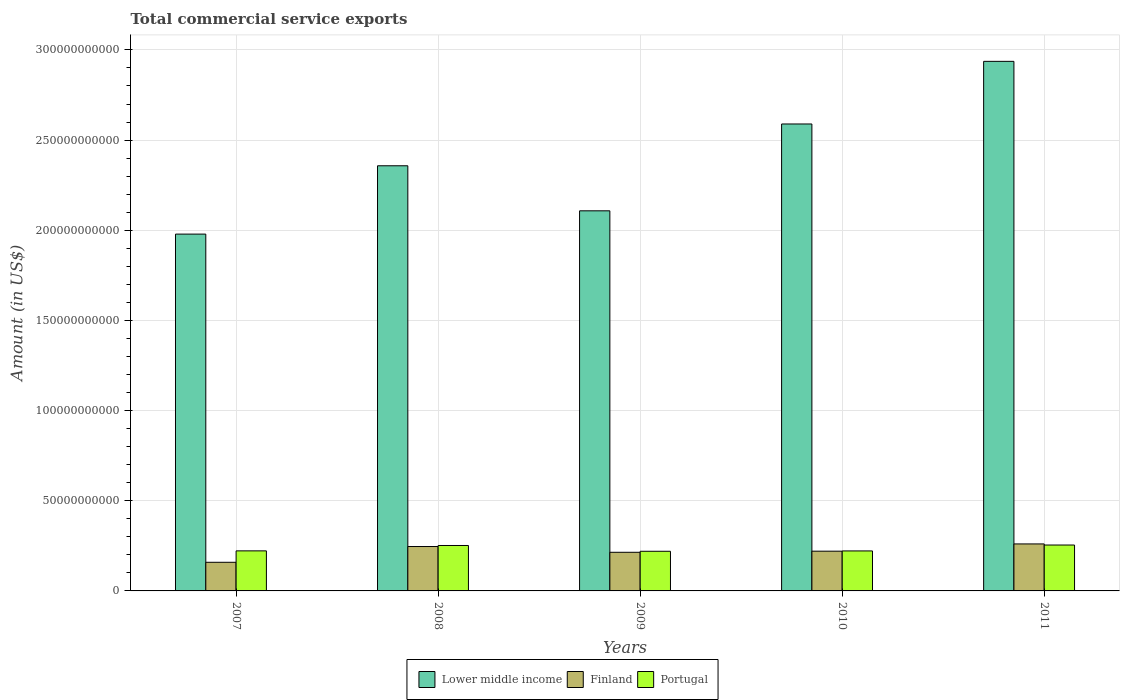How many different coloured bars are there?
Make the answer very short. 3. How many bars are there on the 1st tick from the left?
Keep it short and to the point. 3. What is the total commercial service exports in Lower middle income in 2011?
Your response must be concise. 2.94e+11. Across all years, what is the maximum total commercial service exports in Finland?
Offer a terse response. 2.61e+1. Across all years, what is the minimum total commercial service exports in Lower middle income?
Provide a succinct answer. 1.98e+11. In which year was the total commercial service exports in Lower middle income maximum?
Give a very brief answer. 2011. In which year was the total commercial service exports in Portugal minimum?
Your response must be concise. 2009. What is the total total commercial service exports in Finland in the graph?
Provide a succinct answer. 1.10e+11. What is the difference between the total commercial service exports in Lower middle income in 2009 and that in 2010?
Give a very brief answer. -4.82e+1. What is the difference between the total commercial service exports in Finland in 2008 and the total commercial service exports in Lower middle income in 2010?
Ensure brevity in your answer.  -2.34e+11. What is the average total commercial service exports in Finland per year?
Your response must be concise. 2.20e+1. In the year 2007, what is the difference between the total commercial service exports in Lower middle income and total commercial service exports in Portugal?
Your answer should be compact. 1.76e+11. What is the ratio of the total commercial service exports in Finland in 2007 to that in 2009?
Keep it short and to the point. 0.74. Is the total commercial service exports in Finland in 2008 less than that in 2010?
Offer a very short reply. No. What is the difference between the highest and the second highest total commercial service exports in Lower middle income?
Offer a very short reply. 3.47e+1. What is the difference between the highest and the lowest total commercial service exports in Finland?
Provide a succinct answer. 1.02e+1. In how many years, is the total commercial service exports in Portugal greater than the average total commercial service exports in Portugal taken over all years?
Offer a very short reply. 2. Is the sum of the total commercial service exports in Portugal in 2008 and 2011 greater than the maximum total commercial service exports in Lower middle income across all years?
Your response must be concise. No. What does the 1st bar from the left in 2011 represents?
Ensure brevity in your answer.  Lower middle income. What does the 1st bar from the right in 2008 represents?
Ensure brevity in your answer.  Portugal. How many bars are there?
Give a very brief answer. 15. Are all the bars in the graph horizontal?
Provide a succinct answer. No. Are the values on the major ticks of Y-axis written in scientific E-notation?
Offer a terse response. No. Does the graph contain any zero values?
Offer a very short reply. No. How many legend labels are there?
Make the answer very short. 3. What is the title of the graph?
Keep it short and to the point. Total commercial service exports. What is the label or title of the Y-axis?
Make the answer very short. Amount (in US$). What is the Amount (in US$) of Lower middle income in 2007?
Your answer should be very brief. 1.98e+11. What is the Amount (in US$) of Finland in 2007?
Offer a very short reply. 1.59e+1. What is the Amount (in US$) of Portugal in 2007?
Offer a very short reply. 2.22e+1. What is the Amount (in US$) in Lower middle income in 2008?
Offer a very short reply. 2.36e+11. What is the Amount (in US$) in Finland in 2008?
Ensure brevity in your answer.  2.46e+1. What is the Amount (in US$) in Portugal in 2008?
Ensure brevity in your answer.  2.52e+1. What is the Amount (in US$) of Lower middle income in 2009?
Keep it short and to the point. 2.11e+11. What is the Amount (in US$) in Finland in 2009?
Provide a succinct answer. 2.14e+1. What is the Amount (in US$) of Portugal in 2009?
Offer a very short reply. 2.20e+1. What is the Amount (in US$) in Lower middle income in 2010?
Your answer should be very brief. 2.59e+11. What is the Amount (in US$) of Finland in 2010?
Your answer should be compact. 2.20e+1. What is the Amount (in US$) of Portugal in 2010?
Offer a very short reply. 2.22e+1. What is the Amount (in US$) in Lower middle income in 2011?
Offer a terse response. 2.94e+11. What is the Amount (in US$) of Finland in 2011?
Provide a succinct answer. 2.61e+1. What is the Amount (in US$) of Portugal in 2011?
Give a very brief answer. 2.55e+1. Across all years, what is the maximum Amount (in US$) of Lower middle income?
Provide a short and direct response. 2.94e+11. Across all years, what is the maximum Amount (in US$) in Finland?
Ensure brevity in your answer.  2.61e+1. Across all years, what is the maximum Amount (in US$) of Portugal?
Offer a terse response. 2.55e+1. Across all years, what is the minimum Amount (in US$) of Lower middle income?
Offer a terse response. 1.98e+11. Across all years, what is the minimum Amount (in US$) of Finland?
Give a very brief answer. 1.59e+1. Across all years, what is the minimum Amount (in US$) of Portugal?
Your answer should be compact. 2.20e+1. What is the total Amount (in US$) of Lower middle income in the graph?
Provide a short and direct response. 1.20e+12. What is the total Amount (in US$) in Finland in the graph?
Your response must be concise. 1.10e+11. What is the total Amount (in US$) in Portugal in the graph?
Your answer should be compact. 1.17e+11. What is the difference between the Amount (in US$) in Lower middle income in 2007 and that in 2008?
Offer a very short reply. -3.79e+1. What is the difference between the Amount (in US$) in Finland in 2007 and that in 2008?
Your answer should be very brief. -8.74e+09. What is the difference between the Amount (in US$) of Portugal in 2007 and that in 2008?
Provide a succinct answer. -2.98e+09. What is the difference between the Amount (in US$) in Lower middle income in 2007 and that in 2009?
Provide a short and direct response. -1.29e+1. What is the difference between the Amount (in US$) in Finland in 2007 and that in 2009?
Your answer should be compact. -5.54e+09. What is the difference between the Amount (in US$) of Portugal in 2007 and that in 2009?
Provide a succinct answer. 2.26e+08. What is the difference between the Amount (in US$) of Lower middle income in 2007 and that in 2010?
Offer a terse response. -6.11e+1. What is the difference between the Amount (in US$) in Finland in 2007 and that in 2010?
Offer a terse response. -6.16e+09. What is the difference between the Amount (in US$) in Portugal in 2007 and that in 2010?
Provide a succinct answer. 3.52e+07. What is the difference between the Amount (in US$) in Lower middle income in 2007 and that in 2011?
Give a very brief answer. -9.58e+1. What is the difference between the Amount (in US$) of Finland in 2007 and that in 2011?
Offer a terse response. -1.02e+1. What is the difference between the Amount (in US$) in Portugal in 2007 and that in 2011?
Provide a succinct answer. -3.24e+09. What is the difference between the Amount (in US$) in Lower middle income in 2008 and that in 2009?
Provide a short and direct response. 2.50e+1. What is the difference between the Amount (in US$) in Finland in 2008 and that in 2009?
Make the answer very short. 3.20e+09. What is the difference between the Amount (in US$) in Portugal in 2008 and that in 2009?
Ensure brevity in your answer.  3.21e+09. What is the difference between the Amount (in US$) of Lower middle income in 2008 and that in 2010?
Ensure brevity in your answer.  -2.32e+1. What is the difference between the Amount (in US$) of Finland in 2008 and that in 2010?
Provide a succinct answer. 2.58e+09. What is the difference between the Amount (in US$) of Portugal in 2008 and that in 2010?
Your response must be concise. 3.02e+09. What is the difference between the Amount (in US$) of Lower middle income in 2008 and that in 2011?
Keep it short and to the point. -5.79e+1. What is the difference between the Amount (in US$) in Finland in 2008 and that in 2011?
Keep it short and to the point. -1.44e+09. What is the difference between the Amount (in US$) in Portugal in 2008 and that in 2011?
Provide a short and direct response. -2.59e+08. What is the difference between the Amount (in US$) of Lower middle income in 2009 and that in 2010?
Your answer should be compact. -4.82e+1. What is the difference between the Amount (in US$) of Finland in 2009 and that in 2010?
Make the answer very short. -6.22e+08. What is the difference between the Amount (in US$) of Portugal in 2009 and that in 2010?
Offer a terse response. -1.91e+08. What is the difference between the Amount (in US$) in Lower middle income in 2009 and that in 2011?
Ensure brevity in your answer.  -8.29e+1. What is the difference between the Amount (in US$) of Finland in 2009 and that in 2011?
Your answer should be compact. -4.64e+09. What is the difference between the Amount (in US$) in Portugal in 2009 and that in 2011?
Your answer should be compact. -3.47e+09. What is the difference between the Amount (in US$) of Lower middle income in 2010 and that in 2011?
Offer a very short reply. -3.47e+1. What is the difference between the Amount (in US$) of Finland in 2010 and that in 2011?
Offer a terse response. -4.02e+09. What is the difference between the Amount (in US$) of Portugal in 2010 and that in 2011?
Keep it short and to the point. -3.28e+09. What is the difference between the Amount (in US$) in Lower middle income in 2007 and the Amount (in US$) in Finland in 2008?
Provide a short and direct response. 1.73e+11. What is the difference between the Amount (in US$) of Lower middle income in 2007 and the Amount (in US$) of Portugal in 2008?
Offer a terse response. 1.73e+11. What is the difference between the Amount (in US$) in Finland in 2007 and the Amount (in US$) in Portugal in 2008?
Provide a short and direct response. -9.31e+09. What is the difference between the Amount (in US$) of Lower middle income in 2007 and the Amount (in US$) of Finland in 2009?
Keep it short and to the point. 1.76e+11. What is the difference between the Amount (in US$) of Lower middle income in 2007 and the Amount (in US$) of Portugal in 2009?
Offer a terse response. 1.76e+11. What is the difference between the Amount (in US$) of Finland in 2007 and the Amount (in US$) of Portugal in 2009?
Ensure brevity in your answer.  -6.10e+09. What is the difference between the Amount (in US$) in Lower middle income in 2007 and the Amount (in US$) in Finland in 2010?
Your response must be concise. 1.76e+11. What is the difference between the Amount (in US$) in Lower middle income in 2007 and the Amount (in US$) in Portugal in 2010?
Keep it short and to the point. 1.76e+11. What is the difference between the Amount (in US$) of Finland in 2007 and the Amount (in US$) of Portugal in 2010?
Make the answer very short. -6.30e+09. What is the difference between the Amount (in US$) in Lower middle income in 2007 and the Amount (in US$) in Finland in 2011?
Your answer should be very brief. 1.72e+11. What is the difference between the Amount (in US$) of Lower middle income in 2007 and the Amount (in US$) of Portugal in 2011?
Offer a terse response. 1.72e+11. What is the difference between the Amount (in US$) of Finland in 2007 and the Amount (in US$) of Portugal in 2011?
Your response must be concise. -9.57e+09. What is the difference between the Amount (in US$) in Lower middle income in 2008 and the Amount (in US$) in Finland in 2009?
Your answer should be compact. 2.14e+11. What is the difference between the Amount (in US$) of Lower middle income in 2008 and the Amount (in US$) of Portugal in 2009?
Ensure brevity in your answer.  2.14e+11. What is the difference between the Amount (in US$) in Finland in 2008 and the Amount (in US$) in Portugal in 2009?
Offer a terse response. 2.63e+09. What is the difference between the Amount (in US$) of Lower middle income in 2008 and the Amount (in US$) of Finland in 2010?
Your answer should be compact. 2.14e+11. What is the difference between the Amount (in US$) of Lower middle income in 2008 and the Amount (in US$) of Portugal in 2010?
Provide a succinct answer. 2.14e+11. What is the difference between the Amount (in US$) of Finland in 2008 and the Amount (in US$) of Portugal in 2010?
Your response must be concise. 2.44e+09. What is the difference between the Amount (in US$) in Lower middle income in 2008 and the Amount (in US$) in Finland in 2011?
Give a very brief answer. 2.10e+11. What is the difference between the Amount (in US$) in Lower middle income in 2008 and the Amount (in US$) in Portugal in 2011?
Your answer should be compact. 2.10e+11. What is the difference between the Amount (in US$) in Finland in 2008 and the Amount (in US$) in Portugal in 2011?
Offer a terse response. -8.36e+08. What is the difference between the Amount (in US$) in Lower middle income in 2009 and the Amount (in US$) in Finland in 2010?
Keep it short and to the point. 1.89e+11. What is the difference between the Amount (in US$) of Lower middle income in 2009 and the Amount (in US$) of Portugal in 2010?
Give a very brief answer. 1.89e+11. What is the difference between the Amount (in US$) of Finland in 2009 and the Amount (in US$) of Portugal in 2010?
Your answer should be very brief. -7.58e+08. What is the difference between the Amount (in US$) of Lower middle income in 2009 and the Amount (in US$) of Finland in 2011?
Your answer should be very brief. 1.85e+11. What is the difference between the Amount (in US$) of Lower middle income in 2009 and the Amount (in US$) of Portugal in 2011?
Give a very brief answer. 1.85e+11. What is the difference between the Amount (in US$) in Finland in 2009 and the Amount (in US$) in Portugal in 2011?
Offer a very short reply. -4.03e+09. What is the difference between the Amount (in US$) in Lower middle income in 2010 and the Amount (in US$) in Finland in 2011?
Your response must be concise. 2.33e+11. What is the difference between the Amount (in US$) of Lower middle income in 2010 and the Amount (in US$) of Portugal in 2011?
Your response must be concise. 2.33e+11. What is the difference between the Amount (in US$) in Finland in 2010 and the Amount (in US$) in Portugal in 2011?
Make the answer very short. -3.41e+09. What is the average Amount (in US$) of Lower middle income per year?
Provide a succinct answer. 2.39e+11. What is the average Amount (in US$) in Finland per year?
Provide a short and direct response. 2.20e+1. What is the average Amount (in US$) of Portugal per year?
Provide a succinct answer. 2.34e+1. In the year 2007, what is the difference between the Amount (in US$) in Lower middle income and Amount (in US$) in Finland?
Keep it short and to the point. 1.82e+11. In the year 2007, what is the difference between the Amount (in US$) of Lower middle income and Amount (in US$) of Portugal?
Offer a terse response. 1.76e+11. In the year 2007, what is the difference between the Amount (in US$) of Finland and Amount (in US$) of Portugal?
Offer a very short reply. -6.33e+09. In the year 2008, what is the difference between the Amount (in US$) in Lower middle income and Amount (in US$) in Finland?
Offer a terse response. 2.11e+11. In the year 2008, what is the difference between the Amount (in US$) of Lower middle income and Amount (in US$) of Portugal?
Ensure brevity in your answer.  2.11e+11. In the year 2008, what is the difference between the Amount (in US$) in Finland and Amount (in US$) in Portugal?
Ensure brevity in your answer.  -5.77e+08. In the year 2009, what is the difference between the Amount (in US$) of Lower middle income and Amount (in US$) of Finland?
Offer a very short reply. 1.89e+11. In the year 2009, what is the difference between the Amount (in US$) of Lower middle income and Amount (in US$) of Portugal?
Ensure brevity in your answer.  1.89e+11. In the year 2009, what is the difference between the Amount (in US$) in Finland and Amount (in US$) in Portugal?
Make the answer very short. -5.67e+08. In the year 2010, what is the difference between the Amount (in US$) in Lower middle income and Amount (in US$) in Finland?
Your answer should be compact. 2.37e+11. In the year 2010, what is the difference between the Amount (in US$) in Lower middle income and Amount (in US$) in Portugal?
Your answer should be compact. 2.37e+11. In the year 2010, what is the difference between the Amount (in US$) in Finland and Amount (in US$) in Portugal?
Ensure brevity in your answer.  -1.35e+08. In the year 2011, what is the difference between the Amount (in US$) in Lower middle income and Amount (in US$) in Finland?
Your response must be concise. 2.68e+11. In the year 2011, what is the difference between the Amount (in US$) in Lower middle income and Amount (in US$) in Portugal?
Your answer should be compact. 2.68e+11. In the year 2011, what is the difference between the Amount (in US$) of Finland and Amount (in US$) of Portugal?
Keep it short and to the point. 6.03e+08. What is the ratio of the Amount (in US$) in Lower middle income in 2007 to that in 2008?
Ensure brevity in your answer.  0.84. What is the ratio of the Amount (in US$) of Finland in 2007 to that in 2008?
Offer a terse response. 0.65. What is the ratio of the Amount (in US$) in Portugal in 2007 to that in 2008?
Provide a short and direct response. 0.88. What is the ratio of the Amount (in US$) of Lower middle income in 2007 to that in 2009?
Offer a terse response. 0.94. What is the ratio of the Amount (in US$) of Finland in 2007 to that in 2009?
Provide a succinct answer. 0.74. What is the ratio of the Amount (in US$) in Portugal in 2007 to that in 2009?
Provide a succinct answer. 1.01. What is the ratio of the Amount (in US$) in Lower middle income in 2007 to that in 2010?
Offer a very short reply. 0.76. What is the ratio of the Amount (in US$) in Finland in 2007 to that in 2010?
Provide a short and direct response. 0.72. What is the ratio of the Amount (in US$) in Portugal in 2007 to that in 2010?
Your response must be concise. 1. What is the ratio of the Amount (in US$) of Lower middle income in 2007 to that in 2011?
Provide a succinct answer. 0.67. What is the ratio of the Amount (in US$) of Finland in 2007 to that in 2011?
Give a very brief answer. 0.61. What is the ratio of the Amount (in US$) of Portugal in 2007 to that in 2011?
Offer a terse response. 0.87. What is the ratio of the Amount (in US$) of Lower middle income in 2008 to that in 2009?
Your answer should be very brief. 1.12. What is the ratio of the Amount (in US$) of Finland in 2008 to that in 2009?
Give a very brief answer. 1.15. What is the ratio of the Amount (in US$) in Portugal in 2008 to that in 2009?
Give a very brief answer. 1.15. What is the ratio of the Amount (in US$) in Lower middle income in 2008 to that in 2010?
Ensure brevity in your answer.  0.91. What is the ratio of the Amount (in US$) in Finland in 2008 to that in 2010?
Your answer should be compact. 1.12. What is the ratio of the Amount (in US$) in Portugal in 2008 to that in 2010?
Your answer should be compact. 1.14. What is the ratio of the Amount (in US$) in Lower middle income in 2008 to that in 2011?
Your answer should be compact. 0.8. What is the ratio of the Amount (in US$) in Finland in 2008 to that in 2011?
Ensure brevity in your answer.  0.94. What is the ratio of the Amount (in US$) of Portugal in 2008 to that in 2011?
Give a very brief answer. 0.99. What is the ratio of the Amount (in US$) in Lower middle income in 2009 to that in 2010?
Offer a terse response. 0.81. What is the ratio of the Amount (in US$) of Finland in 2009 to that in 2010?
Your response must be concise. 0.97. What is the ratio of the Amount (in US$) of Lower middle income in 2009 to that in 2011?
Make the answer very short. 0.72. What is the ratio of the Amount (in US$) of Finland in 2009 to that in 2011?
Your answer should be compact. 0.82. What is the ratio of the Amount (in US$) in Portugal in 2009 to that in 2011?
Your answer should be compact. 0.86. What is the ratio of the Amount (in US$) of Lower middle income in 2010 to that in 2011?
Ensure brevity in your answer.  0.88. What is the ratio of the Amount (in US$) in Finland in 2010 to that in 2011?
Your response must be concise. 0.85. What is the ratio of the Amount (in US$) of Portugal in 2010 to that in 2011?
Ensure brevity in your answer.  0.87. What is the difference between the highest and the second highest Amount (in US$) of Lower middle income?
Give a very brief answer. 3.47e+1. What is the difference between the highest and the second highest Amount (in US$) in Finland?
Give a very brief answer. 1.44e+09. What is the difference between the highest and the second highest Amount (in US$) in Portugal?
Provide a succinct answer. 2.59e+08. What is the difference between the highest and the lowest Amount (in US$) of Lower middle income?
Keep it short and to the point. 9.58e+1. What is the difference between the highest and the lowest Amount (in US$) of Finland?
Provide a succinct answer. 1.02e+1. What is the difference between the highest and the lowest Amount (in US$) in Portugal?
Your response must be concise. 3.47e+09. 